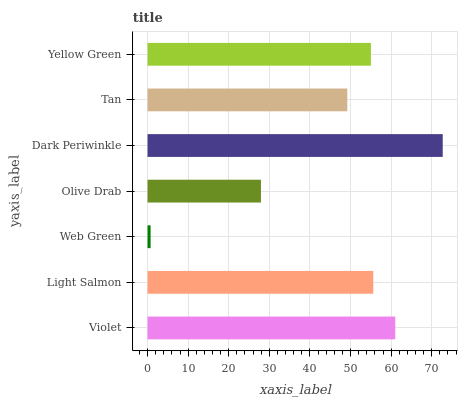Is Web Green the minimum?
Answer yes or no. Yes. Is Dark Periwinkle the maximum?
Answer yes or no. Yes. Is Light Salmon the minimum?
Answer yes or no. No. Is Light Salmon the maximum?
Answer yes or no. No. Is Violet greater than Light Salmon?
Answer yes or no. Yes. Is Light Salmon less than Violet?
Answer yes or no. Yes. Is Light Salmon greater than Violet?
Answer yes or no. No. Is Violet less than Light Salmon?
Answer yes or no. No. Is Yellow Green the high median?
Answer yes or no. Yes. Is Yellow Green the low median?
Answer yes or no. Yes. Is Violet the high median?
Answer yes or no. No. Is Web Green the low median?
Answer yes or no. No. 